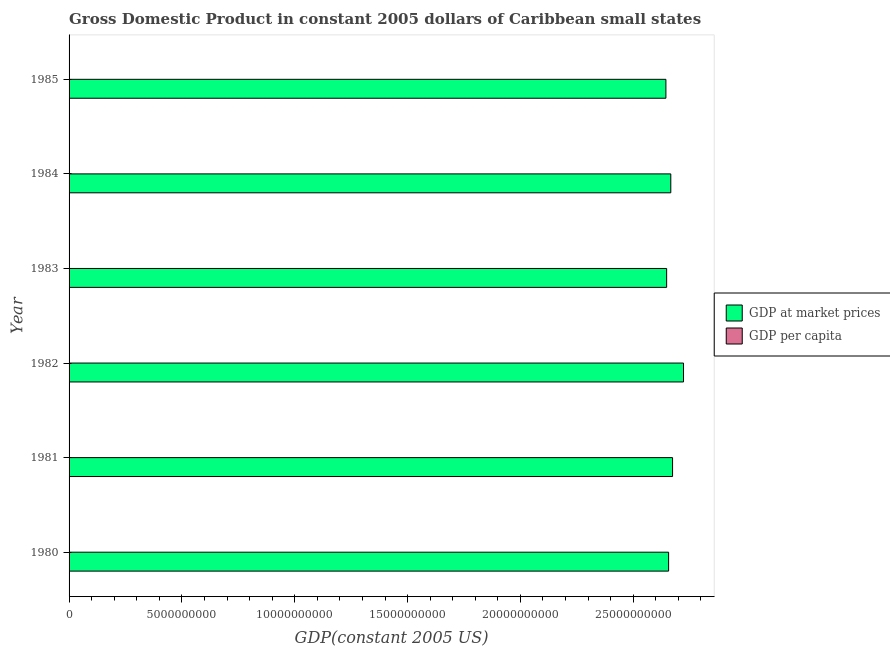How many groups of bars are there?
Your answer should be compact. 6. Are the number of bars per tick equal to the number of legend labels?
Keep it short and to the point. Yes. Are the number of bars on each tick of the Y-axis equal?
Provide a short and direct response. Yes. How many bars are there on the 3rd tick from the bottom?
Make the answer very short. 2. What is the gdp at market prices in 1982?
Offer a terse response. 2.72e+1. Across all years, what is the maximum gdp per capita?
Provide a short and direct response. 4862.81. Across all years, what is the minimum gdp per capita?
Make the answer very short. 4570.72. In which year was the gdp at market prices maximum?
Offer a terse response. 1982. What is the total gdp per capita in the graph?
Provide a short and direct response. 2.84e+04. What is the difference between the gdp at market prices in 1983 and that in 1984?
Provide a short and direct response. -1.84e+08. What is the difference between the gdp at market prices in 1984 and the gdp per capita in 1982?
Your answer should be compact. 2.67e+1. What is the average gdp at market prices per year?
Make the answer very short. 2.67e+1. In the year 1980, what is the difference between the gdp per capita and gdp at market prices?
Give a very brief answer. -2.66e+1. In how many years, is the gdp per capita greater than 15000000000 US$?
Provide a succinct answer. 0. What is the ratio of the gdp at market prices in 1981 to that in 1983?
Make the answer very short. 1.01. What is the difference between the highest and the second highest gdp at market prices?
Provide a short and direct response. 4.85e+08. What is the difference between the highest and the lowest gdp per capita?
Ensure brevity in your answer.  292.09. What does the 2nd bar from the top in 1981 represents?
Offer a very short reply. GDP at market prices. What does the 1st bar from the bottom in 1984 represents?
Offer a very short reply. GDP at market prices. How many bars are there?
Offer a very short reply. 12. What is the difference between two consecutive major ticks on the X-axis?
Your answer should be very brief. 5.00e+09. Does the graph contain grids?
Provide a succinct answer. No. Where does the legend appear in the graph?
Give a very brief answer. Center right. How are the legend labels stacked?
Offer a very short reply. Vertical. What is the title of the graph?
Provide a short and direct response. Gross Domestic Product in constant 2005 dollars of Caribbean small states. What is the label or title of the X-axis?
Your answer should be compact. GDP(constant 2005 US). What is the GDP(constant 2005 US) of GDP at market prices in 1980?
Provide a succinct answer. 2.66e+1. What is the GDP(constant 2005 US) in GDP per capita in 1980?
Give a very brief answer. 4855.96. What is the GDP(constant 2005 US) of GDP at market prices in 1981?
Your answer should be very brief. 2.67e+1. What is the GDP(constant 2005 US) of GDP per capita in 1981?
Your response must be concise. 4834.49. What is the GDP(constant 2005 US) of GDP at market prices in 1982?
Offer a very short reply. 2.72e+1. What is the GDP(constant 2005 US) of GDP per capita in 1982?
Offer a terse response. 4862.81. What is the GDP(constant 2005 US) of GDP at market prices in 1983?
Your answer should be compact. 2.65e+1. What is the GDP(constant 2005 US) of GDP per capita in 1983?
Offer a terse response. 4672.26. What is the GDP(constant 2005 US) of GDP at market prices in 1984?
Your answer should be compact. 2.67e+1. What is the GDP(constant 2005 US) of GDP per capita in 1984?
Offer a very short reply. 4651.7. What is the GDP(constant 2005 US) of GDP at market prices in 1985?
Your answer should be very brief. 2.64e+1. What is the GDP(constant 2005 US) of GDP per capita in 1985?
Offer a terse response. 4570.72. Across all years, what is the maximum GDP(constant 2005 US) in GDP at market prices?
Your response must be concise. 2.72e+1. Across all years, what is the maximum GDP(constant 2005 US) in GDP per capita?
Ensure brevity in your answer.  4862.81. Across all years, what is the minimum GDP(constant 2005 US) of GDP at market prices?
Ensure brevity in your answer.  2.64e+1. Across all years, what is the minimum GDP(constant 2005 US) in GDP per capita?
Provide a short and direct response. 4570.72. What is the total GDP(constant 2005 US) in GDP at market prices in the graph?
Your response must be concise. 1.60e+11. What is the total GDP(constant 2005 US) of GDP per capita in the graph?
Provide a succinct answer. 2.84e+04. What is the difference between the GDP(constant 2005 US) in GDP at market prices in 1980 and that in 1981?
Provide a short and direct response. -1.75e+08. What is the difference between the GDP(constant 2005 US) of GDP per capita in 1980 and that in 1981?
Your answer should be very brief. 21.46. What is the difference between the GDP(constant 2005 US) of GDP at market prices in 1980 and that in 1982?
Your answer should be compact. -6.60e+08. What is the difference between the GDP(constant 2005 US) in GDP per capita in 1980 and that in 1982?
Make the answer very short. -6.85. What is the difference between the GDP(constant 2005 US) in GDP at market prices in 1980 and that in 1983?
Give a very brief answer. 8.68e+07. What is the difference between the GDP(constant 2005 US) in GDP per capita in 1980 and that in 1983?
Offer a very short reply. 183.7. What is the difference between the GDP(constant 2005 US) of GDP at market prices in 1980 and that in 1984?
Give a very brief answer. -9.69e+07. What is the difference between the GDP(constant 2005 US) of GDP per capita in 1980 and that in 1984?
Ensure brevity in your answer.  204.26. What is the difference between the GDP(constant 2005 US) of GDP at market prices in 1980 and that in 1985?
Your answer should be very brief. 1.20e+08. What is the difference between the GDP(constant 2005 US) of GDP per capita in 1980 and that in 1985?
Provide a succinct answer. 285.24. What is the difference between the GDP(constant 2005 US) of GDP at market prices in 1981 and that in 1982?
Give a very brief answer. -4.85e+08. What is the difference between the GDP(constant 2005 US) in GDP per capita in 1981 and that in 1982?
Keep it short and to the point. -28.32. What is the difference between the GDP(constant 2005 US) in GDP at market prices in 1981 and that in 1983?
Your answer should be compact. 2.62e+08. What is the difference between the GDP(constant 2005 US) in GDP per capita in 1981 and that in 1983?
Make the answer very short. 162.24. What is the difference between the GDP(constant 2005 US) of GDP at market prices in 1981 and that in 1984?
Provide a short and direct response. 7.85e+07. What is the difference between the GDP(constant 2005 US) of GDP per capita in 1981 and that in 1984?
Make the answer very short. 182.8. What is the difference between the GDP(constant 2005 US) in GDP at market prices in 1981 and that in 1985?
Your response must be concise. 2.95e+08. What is the difference between the GDP(constant 2005 US) of GDP per capita in 1981 and that in 1985?
Provide a succinct answer. 263.78. What is the difference between the GDP(constant 2005 US) of GDP at market prices in 1982 and that in 1983?
Offer a terse response. 7.47e+08. What is the difference between the GDP(constant 2005 US) of GDP per capita in 1982 and that in 1983?
Your answer should be very brief. 190.55. What is the difference between the GDP(constant 2005 US) in GDP at market prices in 1982 and that in 1984?
Your response must be concise. 5.63e+08. What is the difference between the GDP(constant 2005 US) of GDP per capita in 1982 and that in 1984?
Provide a short and direct response. 211.12. What is the difference between the GDP(constant 2005 US) of GDP at market prices in 1982 and that in 1985?
Your answer should be very brief. 7.80e+08. What is the difference between the GDP(constant 2005 US) of GDP per capita in 1982 and that in 1985?
Provide a succinct answer. 292.09. What is the difference between the GDP(constant 2005 US) of GDP at market prices in 1983 and that in 1984?
Your answer should be compact. -1.84e+08. What is the difference between the GDP(constant 2005 US) of GDP per capita in 1983 and that in 1984?
Make the answer very short. 20.56. What is the difference between the GDP(constant 2005 US) in GDP at market prices in 1983 and that in 1985?
Make the answer very short. 3.28e+07. What is the difference between the GDP(constant 2005 US) of GDP per capita in 1983 and that in 1985?
Your response must be concise. 101.54. What is the difference between the GDP(constant 2005 US) in GDP at market prices in 1984 and that in 1985?
Your answer should be very brief. 2.17e+08. What is the difference between the GDP(constant 2005 US) in GDP per capita in 1984 and that in 1985?
Your response must be concise. 80.98. What is the difference between the GDP(constant 2005 US) of GDP at market prices in 1980 and the GDP(constant 2005 US) of GDP per capita in 1981?
Offer a very short reply. 2.66e+1. What is the difference between the GDP(constant 2005 US) of GDP at market prices in 1980 and the GDP(constant 2005 US) of GDP per capita in 1982?
Ensure brevity in your answer.  2.66e+1. What is the difference between the GDP(constant 2005 US) of GDP at market prices in 1980 and the GDP(constant 2005 US) of GDP per capita in 1983?
Provide a succinct answer. 2.66e+1. What is the difference between the GDP(constant 2005 US) of GDP at market prices in 1980 and the GDP(constant 2005 US) of GDP per capita in 1984?
Provide a succinct answer. 2.66e+1. What is the difference between the GDP(constant 2005 US) of GDP at market prices in 1980 and the GDP(constant 2005 US) of GDP per capita in 1985?
Your response must be concise. 2.66e+1. What is the difference between the GDP(constant 2005 US) of GDP at market prices in 1981 and the GDP(constant 2005 US) of GDP per capita in 1982?
Your answer should be compact. 2.67e+1. What is the difference between the GDP(constant 2005 US) in GDP at market prices in 1981 and the GDP(constant 2005 US) in GDP per capita in 1983?
Offer a terse response. 2.67e+1. What is the difference between the GDP(constant 2005 US) in GDP at market prices in 1981 and the GDP(constant 2005 US) in GDP per capita in 1984?
Keep it short and to the point. 2.67e+1. What is the difference between the GDP(constant 2005 US) in GDP at market prices in 1981 and the GDP(constant 2005 US) in GDP per capita in 1985?
Give a very brief answer. 2.67e+1. What is the difference between the GDP(constant 2005 US) of GDP at market prices in 1982 and the GDP(constant 2005 US) of GDP per capita in 1983?
Your response must be concise. 2.72e+1. What is the difference between the GDP(constant 2005 US) in GDP at market prices in 1982 and the GDP(constant 2005 US) in GDP per capita in 1984?
Offer a terse response. 2.72e+1. What is the difference between the GDP(constant 2005 US) of GDP at market prices in 1982 and the GDP(constant 2005 US) of GDP per capita in 1985?
Provide a succinct answer. 2.72e+1. What is the difference between the GDP(constant 2005 US) in GDP at market prices in 1983 and the GDP(constant 2005 US) in GDP per capita in 1984?
Provide a succinct answer. 2.65e+1. What is the difference between the GDP(constant 2005 US) in GDP at market prices in 1983 and the GDP(constant 2005 US) in GDP per capita in 1985?
Provide a succinct answer. 2.65e+1. What is the difference between the GDP(constant 2005 US) of GDP at market prices in 1984 and the GDP(constant 2005 US) of GDP per capita in 1985?
Ensure brevity in your answer.  2.67e+1. What is the average GDP(constant 2005 US) in GDP at market prices per year?
Offer a very short reply. 2.67e+1. What is the average GDP(constant 2005 US) of GDP per capita per year?
Ensure brevity in your answer.  4741.32. In the year 1980, what is the difference between the GDP(constant 2005 US) of GDP at market prices and GDP(constant 2005 US) of GDP per capita?
Give a very brief answer. 2.66e+1. In the year 1981, what is the difference between the GDP(constant 2005 US) of GDP at market prices and GDP(constant 2005 US) of GDP per capita?
Ensure brevity in your answer.  2.67e+1. In the year 1982, what is the difference between the GDP(constant 2005 US) in GDP at market prices and GDP(constant 2005 US) in GDP per capita?
Your response must be concise. 2.72e+1. In the year 1983, what is the difference between the GDP(constant 2005 US) of GDP at market prices and GDP(constant 2005 US) of GDP per capita?
Give a very brief answer. 2.65e+1. In the year 1984, what is the difference between the GDP(constant 2005 US) in GDP at market prices and GDP(constant 2005 US) in GDP per capita?
Keep it short and to the point. 2.67e+1. In the year 1985, what is the difference between the GDP(constant 2005 US) in GDP at market prices and GDP(constant 2005 US) in GDP per capita?
Ensure brevity in your answer.  2.64e+1. What is the ratio of the GDP(constant 2005 US) of GDP at market prices in 1980 to that in 1982?
Your answer should be compact. 0.98. What is the ratio of the GDP(constant 2005 US) of GDP per capita in 1980 to that in 1982?
Your answer should be compact. 1. What is the ratio of the GDP(constant 2005 US) in GDP per capita in 1980 to that in 1983?
Keep it short and to the point. 1.04. What is the ratio of the GDP(constant 2005 US) of GDP at market prices in 1980 to that in 1984?
Give a very brief answer. 1. What is the ratio of the GDP(constant 2005 US) in GDP per capita in 1980 to that in 1984?
Provide a short and direct response. 1.04. What is the ratio of the GDP(constant 2005 US) in GDP per capita in 1980 to that in 1985?
Offer a terse response. 1.06. What is the ratio of the GDP(constant 2005 US) in GDP at market prices in 1981 to that in 1982?
Give a very brief answer. 0.98. What is the ratio of the GDP(constant 2005 US) of GDP per capita in 1981 to that in 1982?
Give a very brief answer. 0.99. What is the ratio of the GDP(constant 2005 US) of GDP at market prices in 1981 to that in 1983?
Offer a terse response. 1.01. What is the ratio of the GDP(constant 2005 US) of GDP per capita in 1981 to that in 1983?
Offer a terse response. 1.03. What is the ratio of the GDP(constant 2005 US) in GDP per capita in 1981 to that in 1984?
Give a very brief answer. 1.04. What is the ratio of the GDP(constant 2005 US) in GDP at market prices in 1981 to that in 1985?
Offer a terse response. 1.01. What is the ratio of the GDP(constant 2005 US) of GDP per capita in 1981 to that in 1985?
Provide a succinct answer. 1.06. What is the ratio of the GDP(constant 2005 US) in GDP at market prices in 1982 to that in 1983?
Your response must be concise. 1.03. What is the ratio of the GDP(constant 2005 US) of GDP per capita in 1982 to that in 1983?
Offer a terse response. 1.04. What is the ratio of the GDP(constant 2005 US) of GDP at market prices in 1982 to that in 1984?
Offer a very short reply. 1.02. What is the ratio of the GDP(constant 2005 US) in GDP per capita in 1982 to that in 1984?
Ensure brevity in your answer.  1.05. What is the ratio of the GDP(constant 2005 US) in GDP at market prices in 1982 to that in 1985?
Offer a very short reply. 1.03. What is the ratio of the GDP(constant 2005 US) in GDP per capita in 1982 to that in 1985?
Give a very brief answer. 1.06. What is the ratio of the GDP(constant 2005 US) in GDP at market prices in 1983 to that in 1984?
Make the answer very short. 0.99. What is the ratio of the GDP(constant 2005 US) of GDP at market prices in 1983 to that in 1985?
Provide a short and direct response. 1. What is the ratio of the GDP(constant 2005 US) of GDP per capita in 1983 to that in 1985?
Offer a terse response. 1.02. What is the ratio of the GDP(constant 2005 US) of GDP at market prices in 1984 to that in 1985?
Provide a succinct answer. 1.01. What is the ratio of the GDP(constant 2005 US) in GDP per capita in 1984 to that in 1985?
Keep it short and to the point. 1.02. What is the difference between the highest and the second highest GDP(constant 2005 US) in GDP at market prices?
Make the answer very short. 4.85e+08. What is the difference between the highest and the second highest GDP(constant 2005 US) in GDP per capita?
Your answer should be very brief. 6.85. What is the difference between the highest and the lowest GDP(constant 2005 US) in GDP at market prices?
Offer a terse response. 7.80e+08. What is the difference between the highest and the lowest GDP(constant 2005 US) in GDP per capita?
Your answer should be very brief. 292.09. 